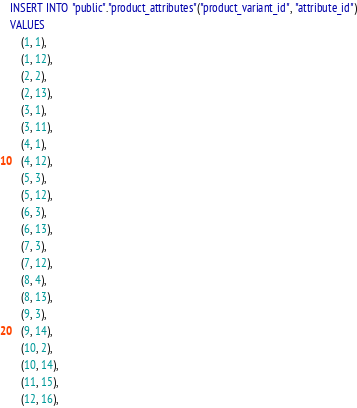Convert code to text. <code><loc_0><loc_0><loc_500><loc_500><_SQL_>INSERT INTO "public"."product_attributes"("product_variant_id", "attribute_id")
VALUES
    (1, 1),
    (1, 12),
    (2, 2),
    (2, 13),
    (3, 1),
    (3, 11),
    (4, 1),
    (4, 12),
    (5, 3),
    (5, 12),
    (6, 3),
    (6, 13),
    (7, 3),
    (7, 12),
    (8, 4),
    (8, 13),
    (9, 3),
    (9, 14),
    (10, 2),
    (10, 14),
    (11, 15),
    (12, 16),</code> 